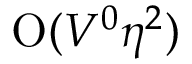Convert formula to latex. <formula><loc_0><loc_0><loc_500><loc_500>O ( V ^ { 0 } \eta ^ { 2 } )</formula> 